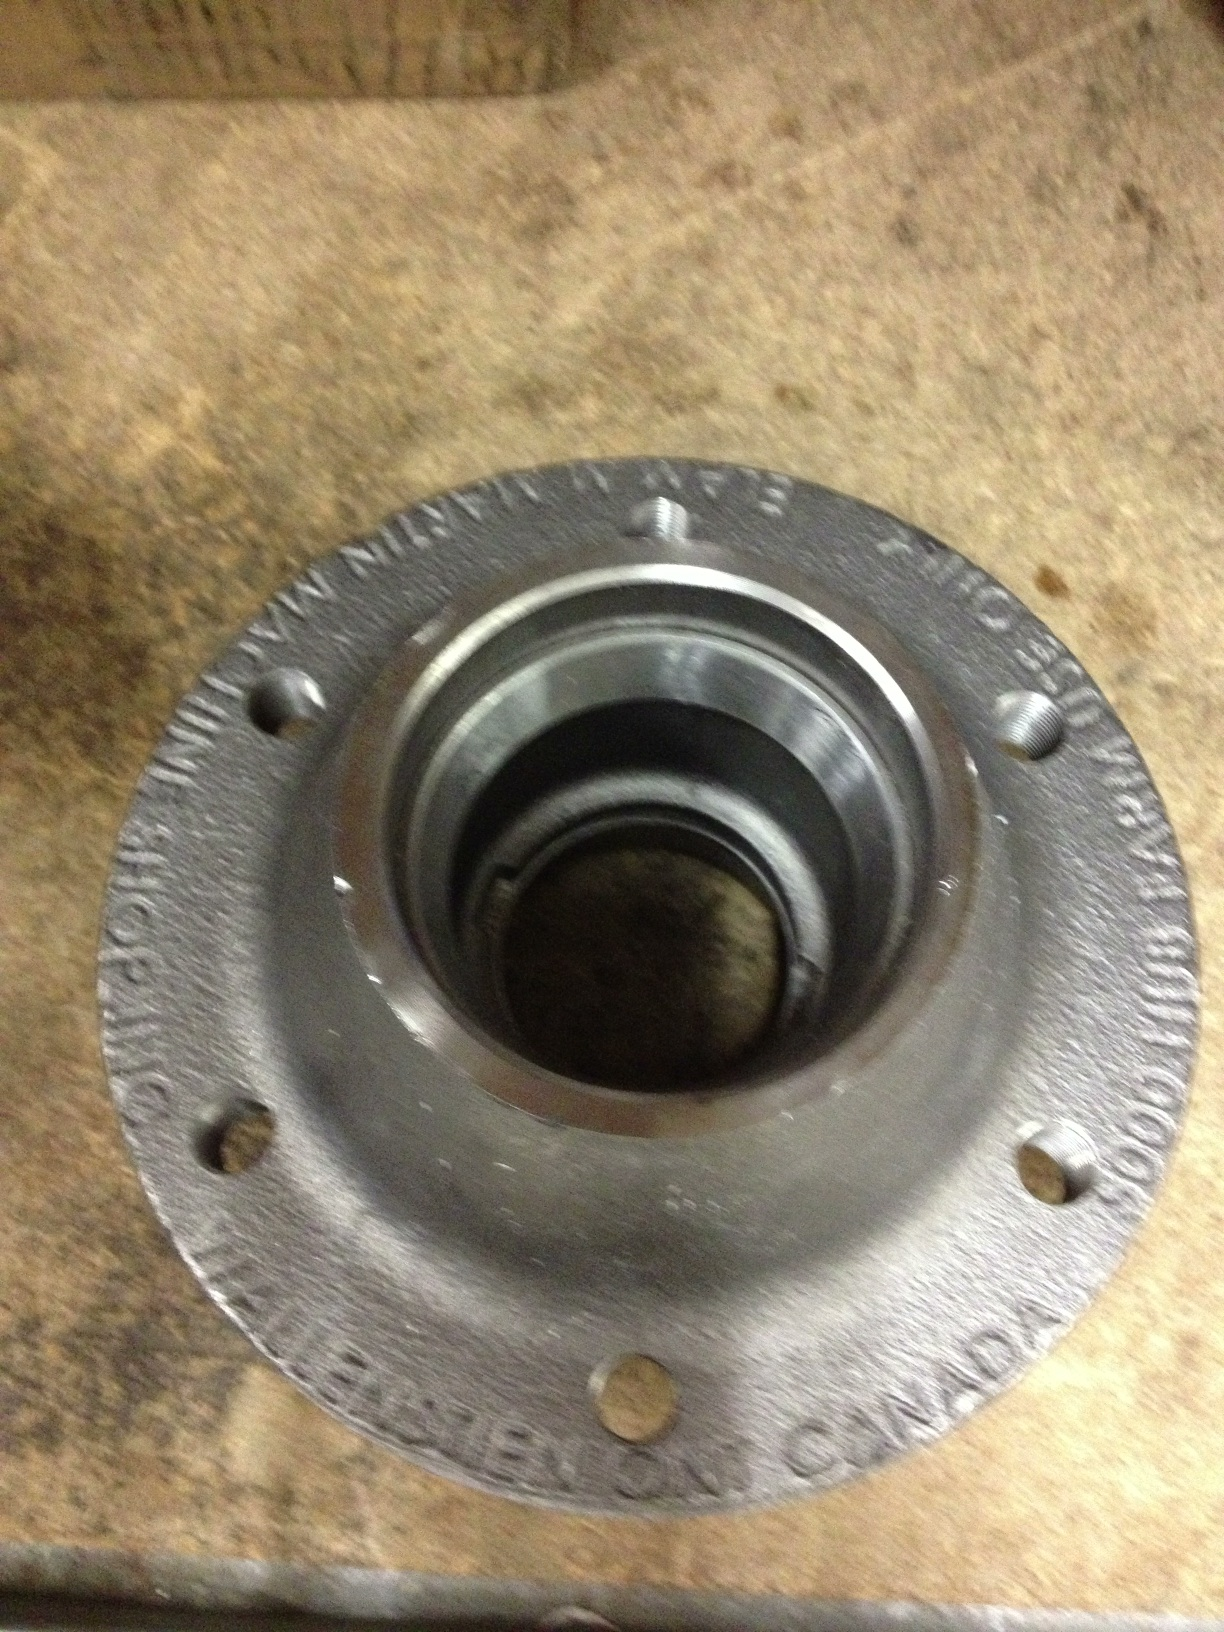what is this? This is a wheel hub, which is a crucial component of a vehicle's wheel assembly. It connects the wheel to the vehicle and ensures that it rotates smoothly. Wheel hubs are important for the overall performance and safety of the car, as they carry the load, facilitate steering, and enable abs sensors. 